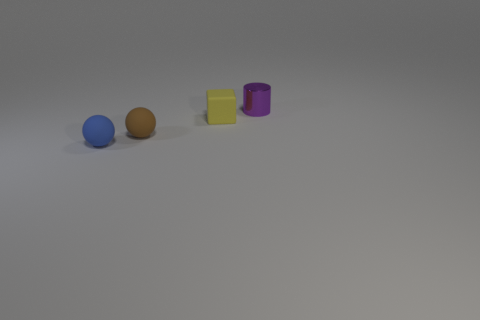What number of other things are the same size as the block?
Make the answer very short. 3. What number of objects are either tiny purple cylinders to the right of the brown rubber sphere or big green things?
Provide a succinct answer. 1. How many things have the same material as the blue sphere?
Offer a terse response. 2. Are there an equal number of purple metal cylinders that are in front of the yellow thing and yellow cubes?
Give a very brief answer. No. How big is the matte thing that is on the right side of the small brown rubber thing?
Keep it short and to the point. Small. How many big things are brown things or purple metallic cylinders?
Offer a very short reply. 0. What is the color of the other object that is the same shape as the blue rubber object?
Provide a short and direct response. Brown. Is the yellow thing the same size as the brown object?
Your response must be concise. Yes. What number of objects are tiny blue blocks or tiny things that are right of the yellow rubber thing?
Ensure brevity in your answer.  1. There is a matte cube that is behind the sphere in front of the brown rubber thing; what color is it?
Your answer should be compact. Yellow. 